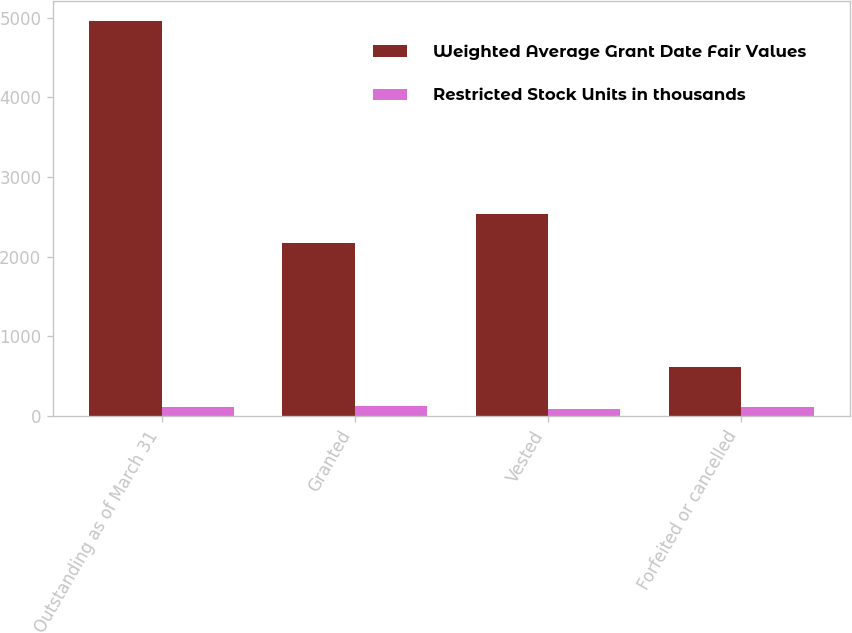<chart> <loc_0><loc_0><loc_500><loc_500><stacked_bar_chart><ecel><fcel>Outstanding as of March 31<fcel>Granted<fcel>Vested<fcel>Forfeited or cancelled<nl><fcel>Weighted Average Grant Date Fair Values<fcel>4960<fcel>2169<fcel>2541<fcel>616<nl><fcel>Restricted Stock Units in thousands<fcel>111.03<fcel>128.76<fcel>88.09<fcel>109.09<nl></chart> 